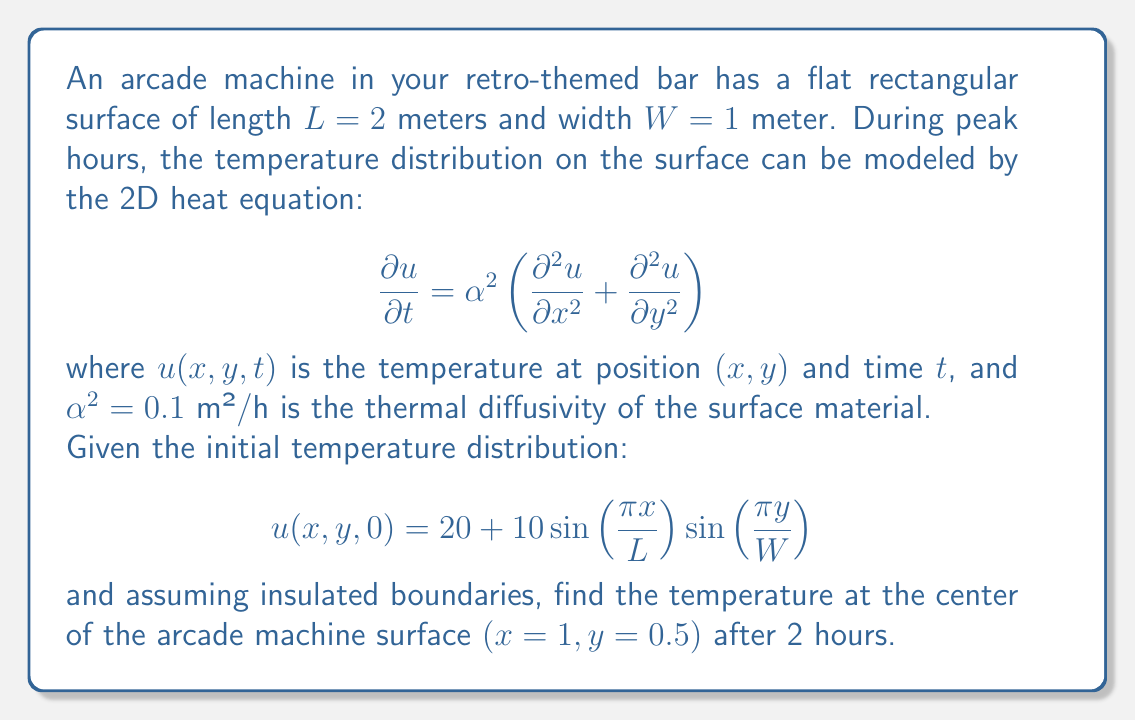Could you help me with this problem? To solve this problem, we'll follow these steps:

1) The general solution to the 2D heat equation with insulated boundaries is:

   $$u(x,y,t) = \sum_{m=0}^{\infty}\sum_{n=0}^{\infty} A_{mn}\cos\left(\frac{m\pi x}{L}\right)\cos\left(\frac{n\pi y}{W}\right)e^{-\alpha^2\pi^2\left(\frac{m^2}{L^2}+\frac{n^2}{W^2}\right)t}$$

2) Our initial condition matches this form with $m=1$, $n=1$, and $A_{11} = 10$. The constant term 20 corresponds to $A_{00} = 20$.

3) Therefore, our solution is:

   $$u(x,y,t) = 20 + 10\sin\left(\frac{\pi x}{L}\right)\sin\left(\frac{\pi y}{W}\right)e^{-\alpha^2\pi^2\left(\frac{1}{L^2}+\frac{1}{W^2}\right)t}$$

4) We need to evaluate this at $x=1$, $y=0.5$, $t=2$, $L=2$, $W=1$, and $\alpha^2 = 0.1$:

   $$u(1,0.5,2) = 20 + 10\sin\left(\frac{\pi}{2}\right)\sin\left(\frac{\pi}{2}\right)e^{-0.1\pi^2\left(\frac{1}{4}+1\right)2}$$

5) Simplify:
   $$u(1,0.5,2) = 20 + 10e^{-0.1\pi^2(1.25)(2)} = 20 + 10e^{-0.25\pi^2}$$

6) Calculate the final result:
   $$u(1,0.5,2) \approx 20 + 10(0.0821) \approx 20.821$$
Answer: 20.82°C 